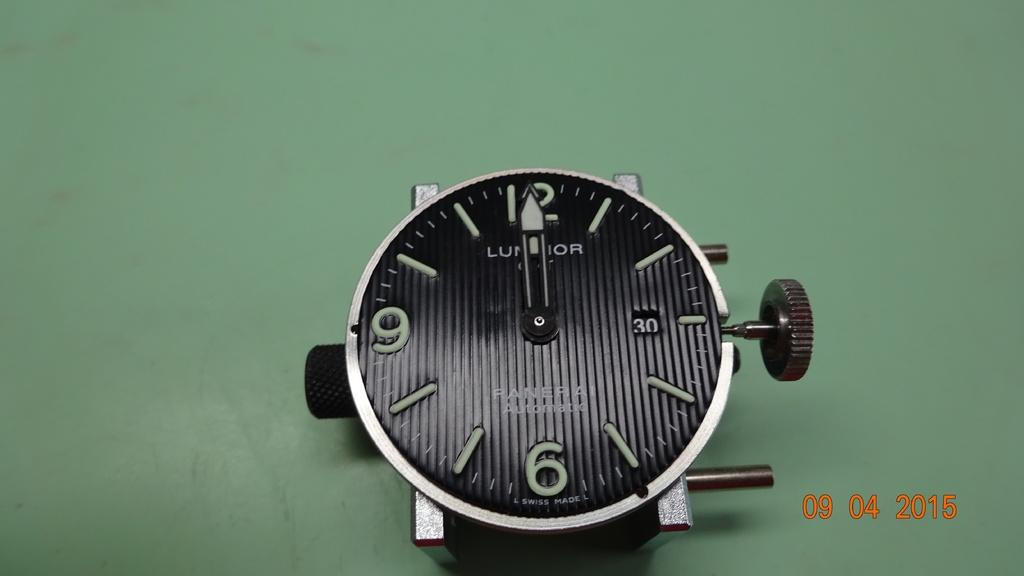<image>
Offer a succinct explanation of the picture presented. the face a black ribbed panera automatic watch 